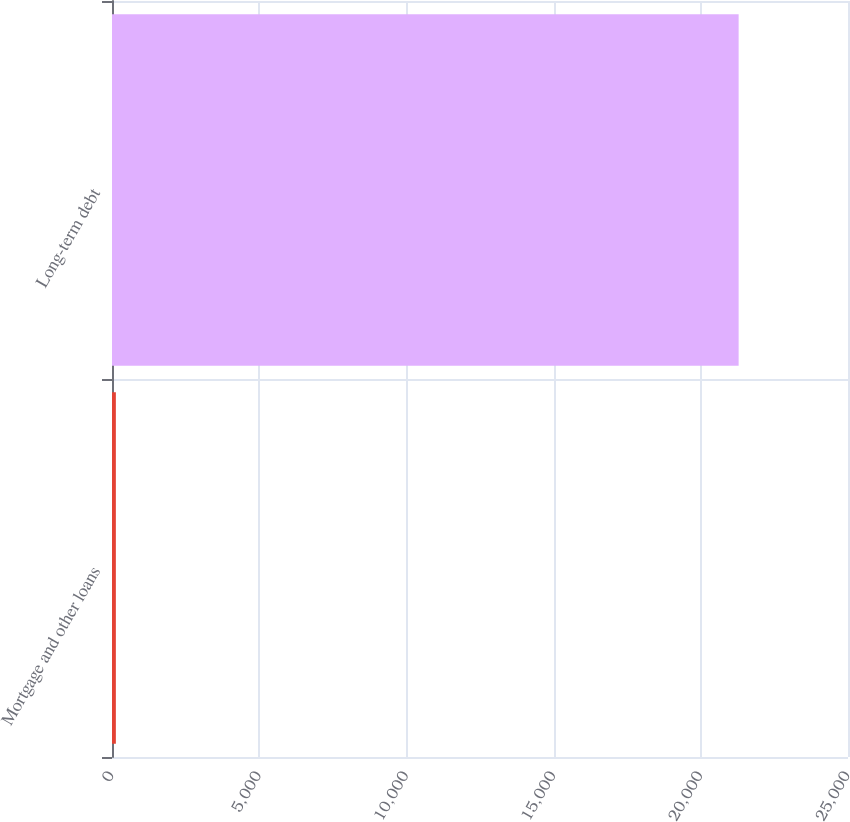Convert chart to OTSL. <chart><loc_0><loc_0><loc_500><loc_500><bar_chart><fcel>Mortgage and other loans<fcel>Long-term debt<nl><fcel>131<fcel>21285<nl></chart> 